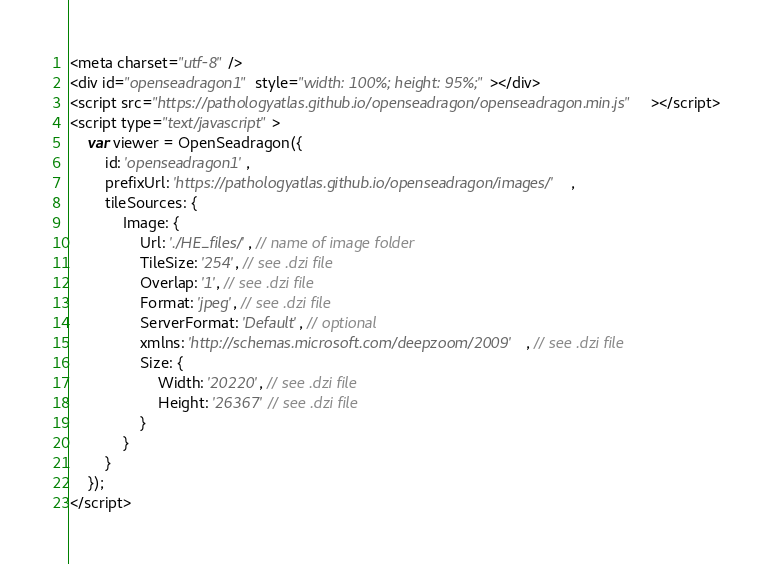<code> <loc_0><loc_0><loc_500><loc_500><_HTML_><meta charset="utf-8" />
<div id="openseadragon1" style="width: 100%; height: 95%;"></div>
<script src="https://pathologyatlas.github.io/openseadragon/openseadragon.min.js"></script>
<script type="text/javascript">
    var viewer = OpenSeadragon({
        id: 'openseadragon1',
        prefixUrl: 'https://pathologyatlas.github.io/openseadragon/images/',
        tileSources: {
            Image: {
                Url: './HE_files/', // name of image folder
                TileSize: '254', // see .dzi file
                Overlap: '1', // see .dzi file
                Format: 'jpeg', // see .dzi file
                ServerFormat: 'Default', // optional
                xmlns: 'http://schemas.microsoft.com/deepzoom/2009', // see .dzi file
                Size: {
                    Width: '20220', // see .dzi file
                    Height: '26367' // see .dzi file
                }
            }
        }
    });
</script></code> 